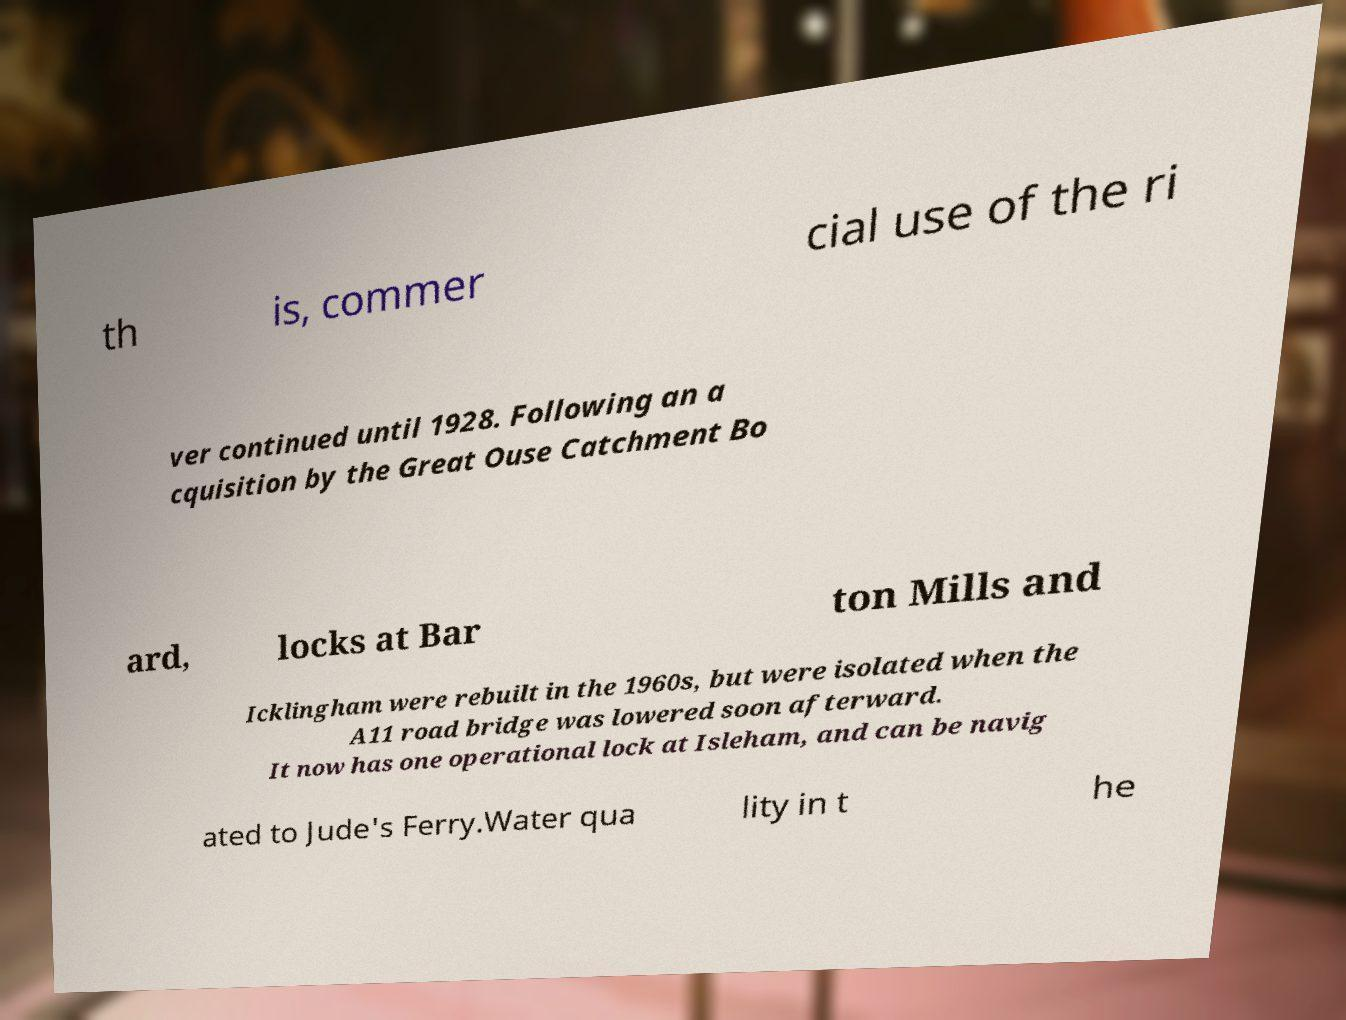Could you extract and type out the text from this image? th is, commer cial use of the ri ver continued until 1928. Following an a cquisition by the Great Ouse Catchment Bo ard, locks at Bar ton Mills and Icklingham were rebuilt in the 1960s, but were isolated when the A11 road bridge was lowered soon afterward. It now has one operational lock at Isleham, and can be navig ated to Jude's Ferry.Water qua lity in t he 